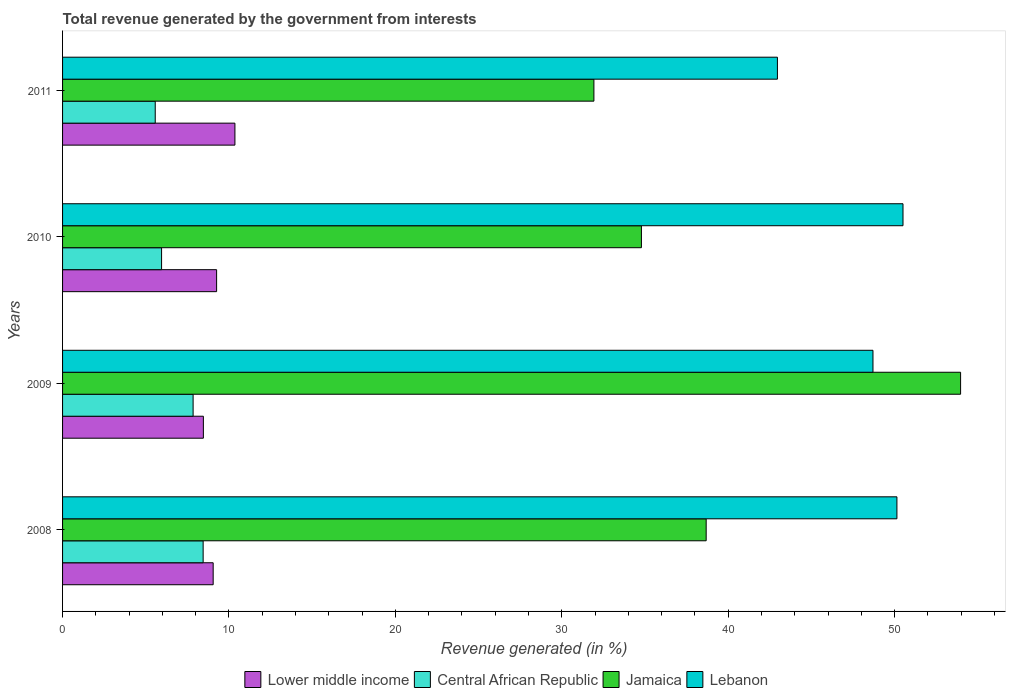How many different coloured bars are there?
Give a very brief answer. 4. In how many cases, is the number of bars for a given year not equal to the number of legend labels?
Keep it short and to the point. 0. What is the total revenue generated in Jamaica in 2009?
Provide a succinct answer. 53.97. Across all years, what is the maximum total revenue generated in Central African Republic?
Your answer should be very brief. 8.45. Across all years, what is the minimum total revenue generated in Jamaica?
Your answer should be compact. 31.93. What is the total total revenue generated in Central African Republic in the graph?
Make the answer very short. 27.81. What is the difference between the total revenue generated in Jamaica in 2008 and that in 2011?
Keep it short and to the point. 6.75. What is the difference between the total revenue generated in Jamaica in 2009 and the total revenue generated in Lebanon in 2011?
Your answer should be very brief. 11.01. What is the average total revenue generated in Lebanon per year?
Your answer should be compact. 48.08. In the year 2009, what is the difference between the total revenue generated in Central African Republic and total revenue generated in Lebanon?
Ensure brevity in your answer.  -40.85. What is the ratio of the total revenue generated in Jamaica in 2010 to that in 2011?
Your response must be concise. 1.09. Is the total revenue generated in Lower middle income in 2008 less than that in 2011?
Make the answer very short. Yes. What is the difference between the highest and the second highest total revenue generated in Central African Republic?
Your response must be concise. 0.6. What is the difference between the highest and the lowest total revenue generated in Lebanon?
Provide a succinct answer. 7.55. Is it the case that in every year, the sum of the total revenue generated in Lebanon and total revenue generated in Jamaica is greater than the sum of total revenue generated in Central African Republic and total revenue generated in Lower middle income?
Ensure brevity in your answer.  No. What does the 1st bar from the top in 2009 represents?
Offer a terse response. Lebanon. What does the 1st bar from the bottom in 2010 represents?
Make the answer very short. Lower middle income. How many bars are there?
Keep it short and to the point. 16. How many years are there in the graph?
Keep it short and to the point. 4. Are the values on the major ticks of X-axis written in scientific E-notation?
Make the answer very short. No. Does the graph contain any zero values?
Keep it short and to the point. No. Where does the legend appear in the graph?
Your response must be concise. Bottom center. How are the legend labels stacked?
Provide a succinct answer. Horizontal. What is the title of the graph?
Offer a very short reply. Total revenue generated by the government from interests. Does "Senegal" appear as one of the legend labels in the graph?
Offer a terse response. No. What is the label or title of the X-axis?
Make the answer very short. Revenue generated (in %). What is the label or title of the Y-axis?
Offer a terse response. Years. What is the Revenue generated (in %) of Lower middle income in 2008?
Provide a short and direct response. 9.05. What is the Revenue generated (in %) in Central African Republic in 2008?
Provide a succinct answer. 8.45. What is the Revenue generated (in %) of Jamaica in 2008?
Provide a succinct answer. 38.68. What is the Revenue generated (in %) in Lebanon in 2008?
Your answer should be very brief. 50.14. What is the Revenue generated (in %) of Lower middle income in 2009?
Your answer should be very brief. 8.46. What is the Revenue generated (in %) of Central African Republic in 2009?
Make the answer very short. 7.85. What is the Revenue generated (in %) of Jamaica in 2009?
Offer a terse response. 53.97. What is the Revenue generated (in %) of Lebanon in 2009?
Offer a terse response. 48.7. What is the Revenue generated (in %) of Lower middle income in 2010?
Your answer should be very brief. 9.26. What is the Revenue generated (in %) in Central African Republic in 2010?
Offer a very short reply. 5.95. What is the Revenue generated (in %) in Jamaica in 2010?
Provide a short and direct response. 34.79. What is the Revenue generated (in %) in Lebanon in 2010?
Your answer should be very brief. 50.5. What is the Revenue generated (in %) of Lower middle income in 2011?
Your response must be concise. 10.36. What is the Revenue generated (in %) of Central African Republic in 2011?
Offer a very short reply. 5.57. What is the Revenue generated (in %) in Jamaica in 2011?
Offer a terse response. 31.93. What is the Revenue generated (in %) of Lebanon in 2011?
Make the answer very short. 42.96. Across all years, what is the maximum Revenue generated (in %) in Lower middle income?
Your answer should be very brief. 10.36. Across all years, what is the maximum Revenue generated (in %) in Central African Republic?
Provide a succinct answer. 8.45. Across all years, what is the maximum Revenue generated (in %) of Jamaica?
Your response must be concise. 53.97. Across all years, what is the maximum Revenue generated (in %) in Lebanon?
Your response must be concise. 50.5. Across all years, what is the minimum Revenue generated (in %) in Lower middle income?
Keep it short and to the point. 8.46. Across all years, what is the minimum Revenue generated (in %) of Central African Republic?
Keep it short and to the point. 5.57. Across all years, what is the minimum Revenue generated (in %) of Jamaica?
Offer a very short reply. 31.93. Across all years, what is the minimum Revenue generated (in %) of Lebanon?
Offer a very short reply. 42.96. What is the total Revenue generated (in %) of Lower middle income in the graph?
Your response must be concise. 37.13. What is the total Revenue generated (in %) in Central African Republic in the graph?
Make the answer very short. 27.81. What is the total Revenue generated (in %) in Jamaica in the graph?
Make the answer very short. 159.36. What is the total Revenue generated (in %) in Lebanon in the graph?
Provide a succinct answer. 192.3. What is the difference between the Revenue generated (in %) of Lower middle income in 2008 and that in 2009?
Offer a terse response. 0.59. What is the difference between the Revenue generated (in %) in Central African Republic in 2008 and that in 2009?
Make the answer very short. 0.6. What is the difference between the Revenue generated (in %) of Jamaica in 2008 and that in 2009?
Make the answer very short. -15.29. What is the difference between the Revenue generated (in %) in Lebanon in 2008 and that in 2009?
Provide a succinct answer. 1.44. What is the difference between the Revenue generated (in %) in Lower middle income in 2008 and that in 2010?
Offer a terse response. -0.21. What is the difference between the Revenue generated (in %) of Central African Republic in 2008 and that in 2010?
Provide a succinct answer. 2.5. What is the difference between the Revenue generated (in %) in Jamaica in 2008 and that in 2010?
Give a very brief answer. 3.89. What is the difference between the Revenue generated (in %) in Lebanon in 2008 and that in 2010?
Your answer should be compact. -0.37. What is the difference between the Revenue generated (in %) of Lower middle income in 2008 and that in 2011?
Provide a succinct answer. -1.31. What is the difference between the Revenue generated (in %) in Central African Republic in 2008 and that in 2011?
Provide a succinct answer. 2.88. What is the difference between the Revenue generated (in %) in Jamaica in 2008 and that in 2011?
Provide a succinct answer. 6.75. What is the difference between the Revenue generated (in %) in Lebanon in 2008 and that in 2011?
Your answer should be very brief. 7.18. What is the difference between the Revenue generated (in %) in Lower middle income in 2009 and that in 2010?
Keep it short and to the point. -0.79. What is the difference between the Revenue generated (in %) of Central African Republic in 2009 and that in 2010?
Offer a very short reply. 1.9. What is the difference between the Revenue generated (in %) in Jamaica in 2009 and that in 2010?
Offer a terse response. 19.18. What is the difference between the Revenue generated (in %) in Lebanon in 2009 and that in 2010?
Provide a succinct answer. -1.8. What is the difference between the Revenue generated (in %) in Lower middle income in 2009 and that in 2011?
Your response must be concise. -1.9. What is the difference between the Revenue generated (in %) of Central African Republic in 2009 and that in 2011?
Make the answer very short. 2.28. What is the difference between the Revenue generated (in %) in Jamaica in 2009 and that in 2011?
Keep it short and to the point. 22.04. What is the difference between the Revenue generated (in %) of Lebanon in 2009 and that in 2011?
Make the answer very short. 5.74. What is the difference between the Revenue generated (in %) in Lower middle income in 2010 and that in 2011?
Your response must be concise. -1.1. What is the difference between the Revenue generated (in %) in Central African Republic in 2010 and that in 2011?
Offer a very short reply. 0.38. What is the difference between the Revenue generated (in %) in Jamaica in 2010 and that in 2011?
Offer a very short reply. 2.86. What is the difference between the Revenue generated (in %) in Lebanon in 2010 and that in 2011?
Provide a succinct answer. 7.55. What is the difference between the Revenue generated (in %) in Lower middle income in 2008 and the Revenue generated (in %) in Central African Republic in 2009?
Your answer should be very brief. 1.21. What is the difference between the Revenue generated (in %) of Lower middle income in 2008 and the Revenue generated (in %) of Jamaica in 2009?
Provide a succinct answer. -44.91. What is the difference between the Revenue generated (in %) in Lower middle income in 2008 and the Revenue generated (in %) in Lebanon in 2009?
Keep it short and to the point. -39.65. What is the difference between the Revenue generated (in %) in Central African Republic in 2008 and the Revenue generated (in %) in Jamaica in 2009?
Offer a terse response. -45.52. What is the difference between the Revenue generated (in %) in Central African Republic in 2008 and the Revenue generated (in %) in Lebanon in 2009?
Provide a succinct answer. -40.25. What is the difference between the Revenue generated (in %) of Jamaica in 2008 and the Revenue generated (in %) of Lebanon in 2009?
Provide a short and direct response. -10.02. What is the difference between the Revenue generated (in %) in Lower middle income in 2008 and the Revenue generated (in %) in Central African Republic in 2010?
Ensure brevity in your answer.  3.1. What is the difference between the Revenue generated (in %) of Lower middle income in 2008 and the Revenue generated (in %) of Jamaica in 2010?
Your response must be concise. -25.74. What is the difference between the Revenue generated (in %) in Lower middle income in 2008 and the Revenue generated (in %) in Lebanon in 2010?
Offer a terse response. -41.45. What is the difference between the Revenue generated (in %) in Central African Republic in 2008 and the Revenue generated (in %) in Jamaica in 2010?
Offer a very short reply. -26.34. What is the difference between the Revenue generated (in %) of Central African Republic in 2008 and the Revenue generated (in %) of Lebanon in 2010?
Your response must be concise. -42.06. What is the difference between the Revenue generated (in %) in Jamaica in 2008 and the Revenue generated (in %) in Lebanon in 2010?
Your response must be concise. -11.83. What is the difference between the Revenue generated (in %) of Lower middle income in 2008 and the Revenue generated (in %) of Central African Republic in 2011?
Keep it short and to the point. 3.48. What is the difference between the Revenue generated (in %) of Lower middle income in 2008 and the Revenue generated (in %) of Jamaica in 2011?
Your answer should be very brief. -22.88. What is the difference between the Revenue generated (in %) in Lower middle income in 2008 and the Revenue generated (in %) in Lebanon in 2011?
Make the answer very short. -33.91. What is the difference between the Revenue generated (in %) of Central African Republic in 2008 and the Revenue generated (in %) of Jamaica in 2011?
Keep it short and to the point. -23.48. What is the difference between the Revenue generated (in %) in Central African Republic in 2008 and the Revenue generated (in %) in Lebanon in 2011?
Your answer should be very brief. -34.51. What is the difference between the Revenue generated (in %) in Jamaica in 2008 and the Revenue generated (in %) in Lebanon in 2011?
Give a very brief answer. -4.28. What is the difference between the Revenue generated (in %) of Lower middle income in 2009 and the Revenue generated (in %) of Central African Republic in 2010?
Provide a succinct answer. 2.51. What is the difference between the Revenue generated (in %) of Lower middle income in 2009 and the Revenue generated (in %) of Jamaica in 2010?
Make the answer very short. -26.32. What is the difference between the Revenue generated (in %) of Lower middle income in 2009 and the Revenue generated (in %) of Lebanon in 2010?
Offer a very short reply. -42.04. What is the difference between the Revenue generated (in %) in Central African Republic in 2009 and the Revenue generated (in %) in Jamaica in 2010?
Your answer should be very brief. -26.94. What is the difference between the Revenue generated (in %) in Central African Republic in 2009 and the Revenue generated (in %) in Lebanon in 2010?
Your response must be concise. -42.66. What is the difference between the Revenue generated (in %) in Jamaica in 2009 and the Revenue generated (in %) in Lebanon in 2010?
Make the answer very short. 3.46. What is the difference between the Revenue generated (in %) of Lower middle income in 2009 and the Revenue generated (in %) of Central African Republic in 2011?
Provide a short and direct response. 2.89. What is the difference between the Revenue generated (in %) in Lower middle income in 2009 and the Revenue generated (in %) in Jamaica in 2011?
Ensure brevity in your answer.  -23.47. What is the difference between the Revenue generated (in %) of Lower middle income in 2009 and the Revenue generated (in %) of Lebanon in 2011?
Your response must be concise. -34.5. What is the difference between the Revenue generated (in %) of Central African Republic in 2009 and the Revenue generated (in %) of Jamaica in 2011?
Your answer should be compact. -24.08. What is the difference between the Revenue generated (in %) in Central African Republic in 2009 and the Revenue generated (in %) in Lebanon in 2011?
Make the answer very short. -35.11. What is the difference between the Revenue generated (in %) in Jamaica in 2009 and the Revenue generated (in %) in Lebanon in 2011?
Your response must be concise. 11.01. What is the difference between the Revenue generated (in %) in Lower middle income in 2010 and the Revenue generated (in %) in Central African Republic in 2011?
Offer a very short reply. 3.69. What is the difference between the Revenue generated (in %) of Lower middle income in 2010 and the Revenue generated (in %) of Jamaica in 2011?
Provide a succinct answer. -22.67. What is the difference between the Revenue generated (in %) in Lower middle income in 2010 and the Revenue generated (in %) in Lebanon in 2011?
Offer a very short reply. -33.7. What is the difference between the Revenue generated (in %) of Central African Republic in 2010 and the Revenue generated (in %) of Jamaica in 2011?
Give a very brief answer. -25.98. What is the difference between the Revenue generated (in %) of Central African Republic in 2010 and the Revenue generated (in %) of Lebanon in 2011?
Ensure brevity in your answer.  -37.01. What is the difference between the Revenue generated (in %) in Jamaica in 2010 and the Revenue generated (in %) in Lebanon in 2011?
Ensure brevity in your answer.  -8.17. What is the average Revenue generated (in %) in Lower middle income per year?
Make the answer very short. 9.28. What is the average Revenue generated (in %) in Central African Republic per year?
Make the answer very short. 6.95. What is the average Revenue generated (in %) of Jamaica per year?
Your response must be concise. 39.84. What is the average Revenue generated (in %) of Lebanon per year?
Your answer should be very brief. 48.08. In the year 2008, what is the difference between the Revenue generated (in %) in Lower middle income and Revenue generated (in %) in Central African Republic?
Give a very brief answer. 0.6. In the year 2008, what is the difference between the Revenue generated (in %) of Lower middle income and Revenue generated (in %) of Jamaica?
Make the answer very short. -29.63. In the year 2008, what is the difference between the Revenue generated (in %) in Lower middle income and Revenue generated (in %) in Lebanon?
Your answer should be compact. -41.09. In the year 2008, what is the difference between the Revenue generated (in %) in Central African Republic and Revenue generated (in %) in Jamaica?
Make the answer very short. -30.23. In the year 2008, what is the difference between the Revenue generated (in %) of Central African Republic and Revenue generated (in %) of Lebanon?
Offer a terse response. -41.69. In the year 2008, what is the difference between the Revenue generated (in %) in Jamaica and Revenue generated (in %) in Lebanon?
Provide a short and direct response. -11.46. In the year 2009, what is the difference between the Revenue generated (in %) in Lower middle income and Revenue generated (in %) in Central African Republic?
Give a very brief answer. 0.62. In the year 2009, what is the difference between the Revenue generated (in %) in Lower middle income and Revenue generated (in %) in Jamaica?
Keep it short and to the point. -45.5. In the year 2009, what is the difference between the Revenue generated (in %) of Lower middle income and Revenue generated (in %) of Lebanon?
Your response must be concise. -40.24. In the year 2009, what is the difference between the Revenue generated (in %) in Central African Republic and Revenue generated (in %) in Jamaica?
Your response must be concise. -46.12. In the year 2009, what is the difference between the Revenue generated (in %) of Central African Republic and Revenue generated (in %) of Lebanon?
Make the answer very short. -40.85. In the year 2009, what is the difference between the Revenue generated (in %) in Jamaica and Revenue generated (in %) in Lebanon?
Keep it short and to the point. 5.27. In the year 2010, what is the difference between the Revenue generated (in %) in Lower middle income and Revenue generated (in %) in Central African Republic?
Offer a terse response. 3.31. In the year 2010, what is the difference between the Revenue generated (in %) in Lower middle income and Revenue generated (in %) in Jamaica?
Ensure brevity in your answer.  -25.53. In the year 2010, what is the difference between the Revenue generated (in %) of Lower middle income and Revenue generated (in %) of Lebanon?
Make the answer very short. -41.25. In the year 2010, what is the difference between the Revenue generated (in %) of Central African Republic and Revenue generated (in %) of Jamaica?
Offer a terse response. -28.84. In the year 2010, what is the difference between the Revenue generated (in %) of Central African Republic and Revenue generated (in %) of Lebanon?
Offer a very short reply. -44.55. In the year 2010, what is the difference between the Revenue generated (in %) in Jamaica and Revenue generated (in %) in Lebanon?
Keep it short and to the point. -15.72. In the year 2011, what is the difference between the Revenue generated (in %) of Lower middle income and Revenue generated (in %) of Central African Republic?
Your answer should be compact. 4.79. In the year 2011, what is the difference between the Revenue generated (in %) in Lower middle income and Revenue generated (in %) in Jamaica?
Your answer should be very brief. -21.57. In the year 2011, what is the difference between the Revenue generated (in %) of Lower middle income and Revenue generated (in %) of Lebanon?
Provide a short and direct response. -32.6. In the year 2011, what is the difference between the Revenue generated (in %) in Central African Republic and Revenue generated (in %) in Jamaica?
Offer a terse response. -26.36. In the year 2011, what is the difference between the Revenue generated (in %) of Central African Republic and Revenue generated (in %) of Lebanon?
Offer a very short reply. -37.39. In the year 2011, what is the difference between the Revenue generated (in %) of Jamaica and Revenue generated (in %) of Lebanon?
Your answer should be compact. -11.03. What is the ratio of the Revenue generated (in %) in Lower middle income in 2008 to that in 2009?
Your answer should be very brief. 1.07. What is the ratio of the Revenue generated (in %) of Central African Republic in 2008 to that in 2009?
Ensure brevity in your answer.  1.08. What is the ratio of the Revenue generated (in %) in Jamaica in 2008 to that in 2009?
Your answer should be compact. 0.72. What is the ratio of the Revenue generated (in %) in Lebanon in 2008 to that in 2009?
Offer a terse response. 1.03. What is the ratio of the Revenue generated (in %) in Lower middle income in 2008 to that in 2010?
Offer a terse response. 0.98. What is the ratio of the Revenue generated (in %) in Central African Republic in 2008 to that in 2010?
Provide a succinct answer. 1.42. What is the ratio of the Revenue generated (in %) in Jamaica in 2008 to that in 2010?
Make the answer very short. 1.11. What is the ratio of the Revenue generated (in %) in Lebanon in 2008 to that in 2010?
Your answer should be compact. 0.99. What is the ratio of the Revenue generated (in %) in Lower middle income in 2008 to that in 2011?
Provide a succinct answer. 0.87. What is the ratio of the Revenue generated (in %) of Central African Republic in 2008 to that in 2011?
Provide a succinct answer. 1.52. What is the ratio of the Revenue generated (in %) in Jamaica in 2008 to that in 2011?
Give a very brief answer. 1.21. What is the ratio of the Revenue generated (in %) in Lebanon in 2008 to that in 2011?
Ensure brevity in your answer.  1.17. What is the ratio of the Revenue generated (in %) of Lower middle income in 2009 to that in 2010?
Make the answer very short. 0.91. What is the ratio of the Revenue generated (in %) of Central African Republic in 2009 to that in 2010?
Offer a very short reply. 1.32. What is the ratio of the Revenue generated (in %) of Jamaica in 2009 to that in 2010?
Offer a very short reply. 1.55. What is the ratio of the Revenue generated (in %) of Lebanon in 2009 to that in 2010?
Make the answer very short. 0.96. What is the ratio of the Revenue generated (in %) of Lower middle income in 2009 to that in 2011?
Your answer should be compact. 0.82. What is the ratio of the Revenue generated (in %) of Central African Republic in 2009 to that in 2011?
Provide a succinct answer. 1.41. What is the ratio of the Revenue generated (in %) of Jamaica in 2009 to that in 2011?
Give a very brief answer. 1.69. What is the ratio of the Revenue generated (in %) in Lebanon in 2009 to that in 2011?
Provide a succinct answer. 1.13. What is the ratio of the Revenue generated (in %) of Lower middle income in 2010 to that in 2011?
Your response must be concise. 0.89. What is the ratio of the Revenue generated (in %) of Central African Republic in 2010 to that in 2011?
Your answer should be very brief. 1.07. What is the ratio of the Revenue generated (in %) in Jamaica in 2010 to that in 2011?
Your answer should be very brief. 1.09. What is the ratio of the Revenue generated (in %) of Lebanon in 2010 to that in 2011?
Ensure brevity in your answer.  1.18. What is the difference between the highest and the second highest Revenue generated (in %) of Lower middle income?
Your answer should be compact. 1.1. What is the difference between the highest and the second highest Revenue generated (in %) in Central African Republic?
Offer a very short reply. 0.6. What is the difference between the highest and the second highest Revenue generated (in %) of Jamaica?
Provide a succinct answer. 15.29. What is the difference between the highest and the second highest Revenue generated (in %) of Lebanon?
Give a very brief answer. 0.37. What is the difference between the highest and the lowest Revenue generated (in %) of Lower middle income?
Your response must be concise. 1.9. What is the difference between the highest and the lowest Revenue generated (in %) in Central African Republic?
Ensure brevity in your answer.  2.88. What is the difference between the highest and the lowest Revenue generated (in %) of Jamaica?
Offer a terse response. 22.04. What is the difference between the highest and the lowest Revenue generated (in %) of Lebanon?
Your answer should be compact. 7.55. 